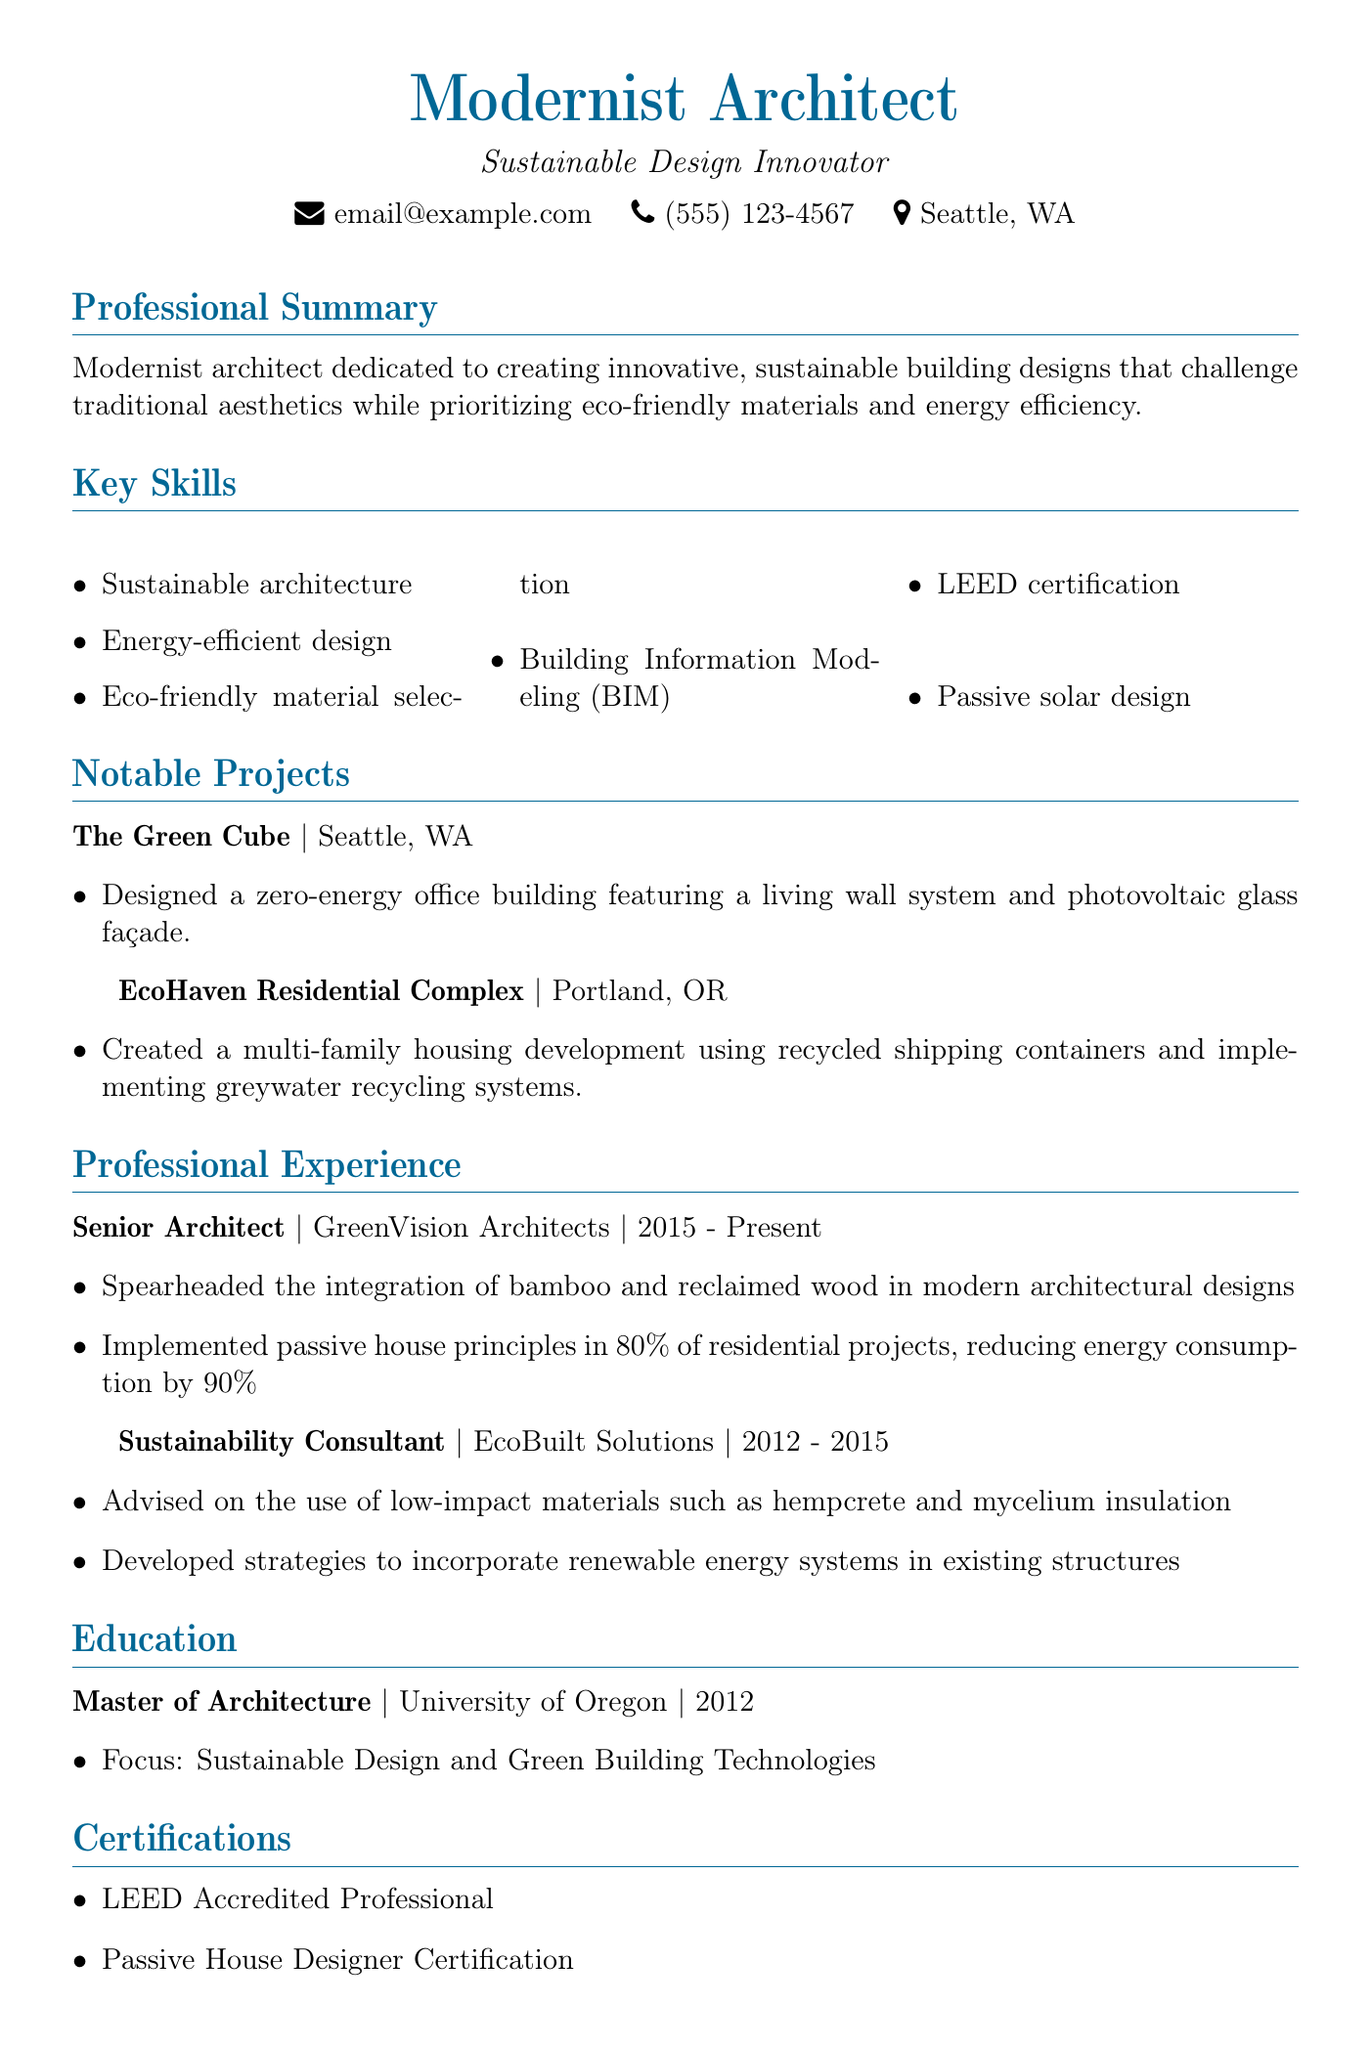What is the main focus of the personal statement? The personal statement emphasizes the architect's dedication to innovative, sustainable building designs with a focus on eco-friendly materials and energy efficiency.
Answer: Innovative, sustainable building designs Where is The Green Cube located? The location for The Green Cube is specified in the notable projects section.
Answer: Seattle, WA What material was used in the EcoHaven Residential Complex? The EcoHaven project description highlights the use of recycled shipping containers.
Answer: Recycled shipping containers When did the architect start working at GreenVision Architects? The professional experience section specifies the start year for the position at GreenVision Architects.
Answer: 2015 How many residential projects implemented passive house principles? The achievements listed under the Senior Architect position indicate the percentage of projects using passive house principles.
Answer: 80 percent Which professional affiliation is related to sustainable architecture? The professional affiliations section includes organizations, with one focusing specifically on sustainable building.
Answer: International Living Future Institute What certification is held by the architect? The certifications section lists the qualifications the architect possesses, one of which is related to green building standards.
Answer: LEED Accredited Professional What was the architect's degree focus? The education section specifies the area of concentration for the master's degree obtained.
Answer: Sustainable Design and Green Building Technologies 